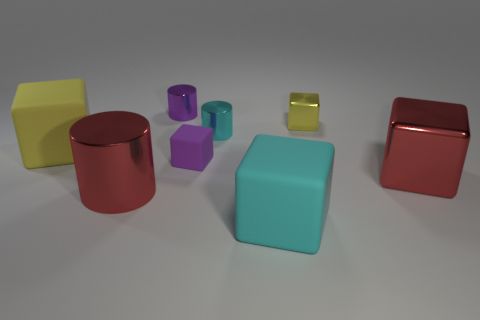Subtract all cyan cubes. How many cubes are left? 4 Subtract all large shiny cubes. How many cubes are left? 4 Subtract all blue cubes. Subtract all yellow spheres. How many cubes are left? 5 Add 1 purple metallic objects. How many objects exist? 9 Subtract all cylinders. How many objects are left? 5 Subtract 0 blue cylinders. How many objects are left? 8 Subtract all large cyan objects. Subtract all tiny rubber blocks. How many objects are left? 6 Add 8 red cylinders. How many red cylinders are left? 9 Add 5 large yellow rubber things. How many large yellow rubber things exist? 6 